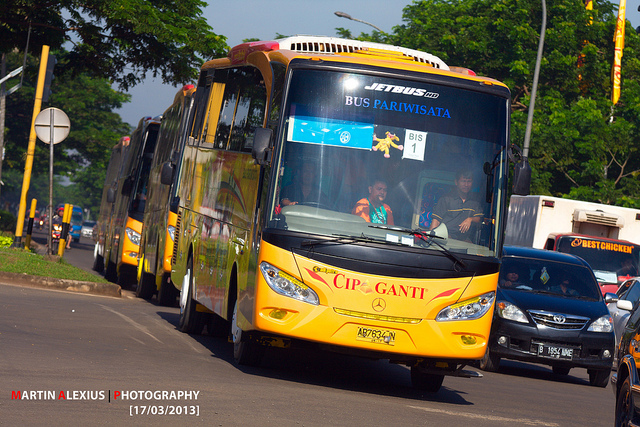How might this scene look in the past, say in the 1950s? In the 1950s, this scene would look quite different. The buses would likely be less modern and more utilitarian, with a simpler design and basic amenities. The street would perhaps appear less developed with narrower lanes and fewer vehicles. The buses might be painted with a more muted color palette, with advertisements or route indicators on the sides. The surrounding area might be less green, reflecting the urban development stage of that era. Bystanders might see people dressed in vintage clothing, adding a nostalgic charm to the bustling scene. 